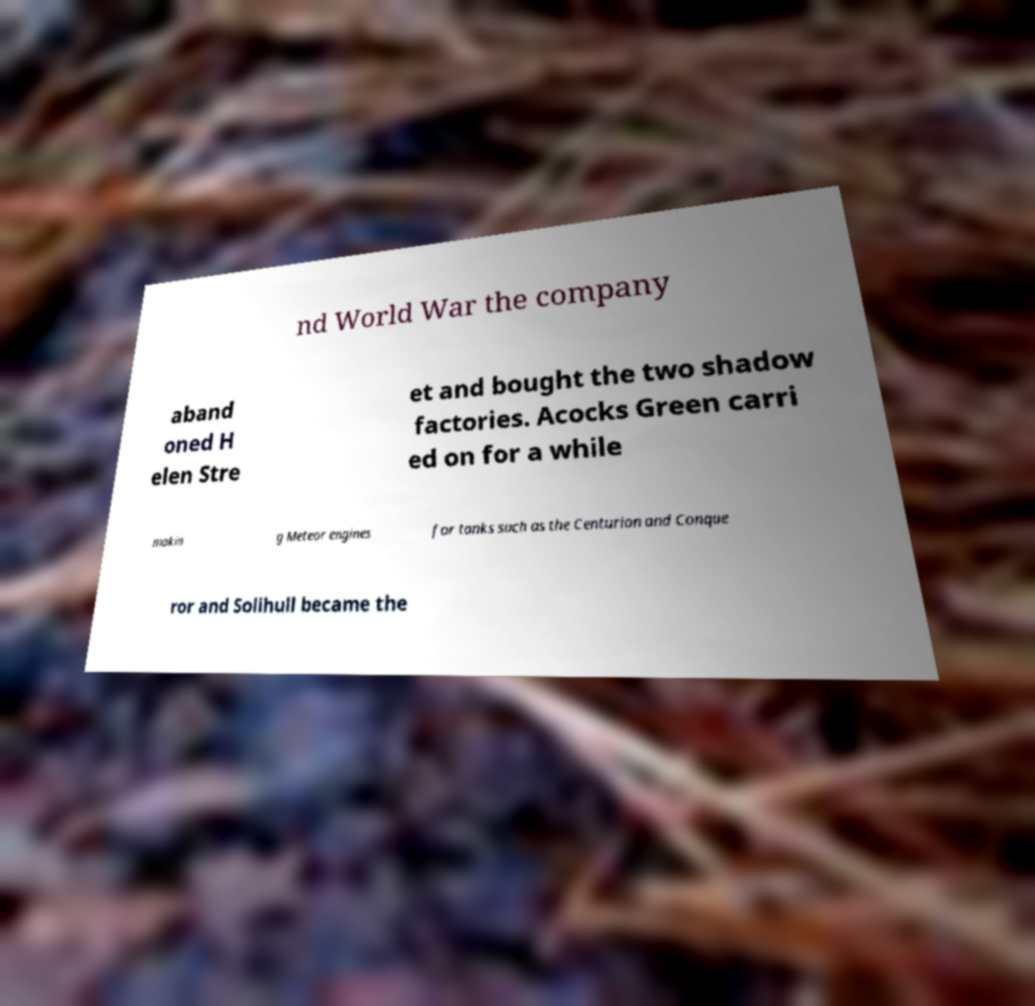Could you assist in decoding the text presented in this image and type it out clearly? nd World War the company aband oned H elen Stre et and bought the two shadow factories. Acocks Green carri ed on for a while makin g Meteor engines for tanks such as the Centurion and Conque ror and Solihull became the 